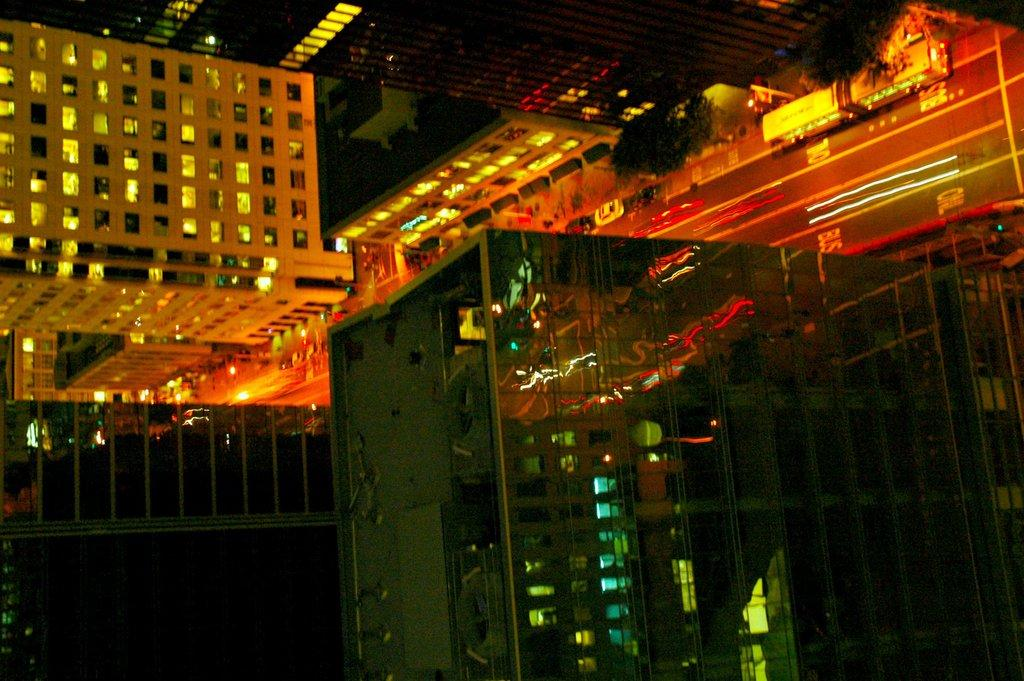What type of structures can be seen in the image? There are buildings in the image. What else is visible in the image besides the buildings? There is a road in the image, as well as vehicles on the road. Are there any natural elements present in the image? Yes, there are trees on the pavement. Where can the store selling jeans be found in the image? There is no store selling jeans present in the image. Can you hear the bell ringing in the image? There is no bell present in the image, so it cannot be heard. 